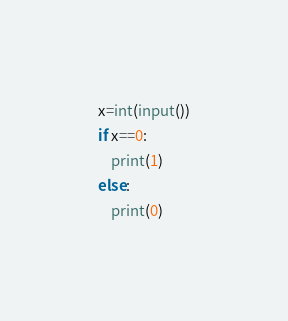Convert code to text. <code><loc_0><loc_0><loc_500><loc_500><_Python_>x=int(input())
if x==0:
    print(1)
else:
    print(0)</code> 